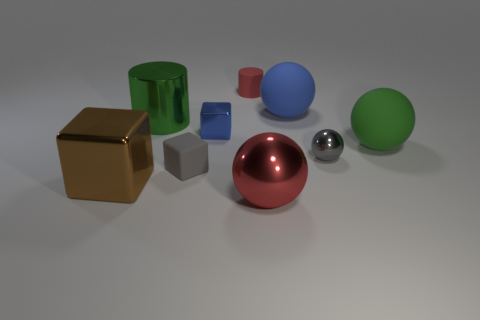There is a large object that is the same color as the tiny matte cylinder; what is it made of?
Ensure brevity in your answer.  Metal. Is the cylinder to the right of the small gray rubber object made of the same material as the sphere in front of the brown metal object?
Make the answer very short. No. Are any blue rubber blocks visible?
Offer a very short reply. No. Is the number of green objects that are on the right side of the red cylinder greater than the number of red metallic spheres on the left side of the big brown block?
Make the answer very short. Yes. There is a blue thing that is the same shape as the big brown metallic object; what is its material?
Give a very brief answer. Metal. There is a small object on the right side of the small red thing; is its color the same as the matte cube that is left of the red shiny object?
Your answer should be compact. Yes. The brown thing is what shape?
Give a very brief answer. Cube. Are there more large red metallic balls that are in front of the large metallic cube than blue metal cylinders?
Your answer should be compact. Yes. There is a blue object to the right of the big red sphere; what shape is it?
Offer a terse response. Sphere. How many other objects are there of the same shape as the large green matte object?
Provide a short and direct response. 3. 